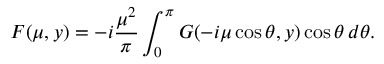<formula> <loc_0><loc_0><loc_500><loc_500>F ( \mu , y ) = - i \frac { { \mu } ^ { 2 } } { \pi } \int _ { 0 } ^ { \pi } G ( - i \mu \cos \theta , y ) \cos \theta \, d \theta .</formula> 